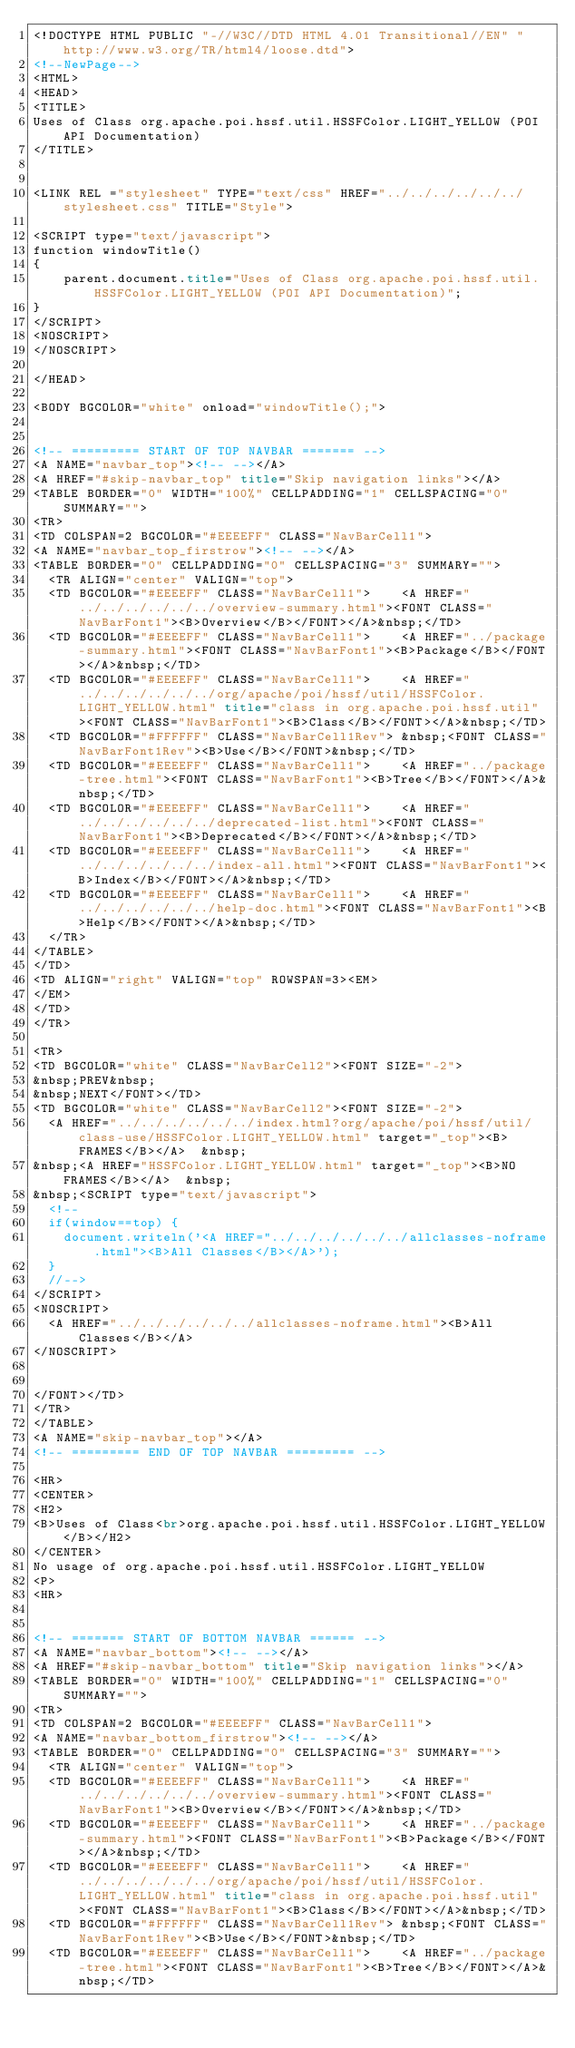<code> <loc_0><loc_0><loc_500><loc_500><_HTML_><!DOCTYPE HTML PUBLIC "-//W3C//DTD HTML 4.01 Transitional//EN" "http://www.w3.org/TR/html4/loose.dtd">
<!--NewPage-->
<HTML>
<HEAD>
<TITLE>
Uses of Class org.apache.poi.hssf.util.HSSFColor.LIGHT_YELLOW (POI API Documentation)
</TITLE>


<LINK REL ="stylesheet" TYPE="text/css" HREF="../../../../../../stylesheet.css" TITLE="Style">

<SCRIPT type="text/javascript">
function windowTitle()
{
    parent.document.title="Uses of Class org.apache.poi.hssf.util.HSSFColor.LIGHT_YELLOW (POI API Documentation)";
}
</SCRIPT>
<NOSCRIPT>
</NOSCRIPT>

</HEAD>

<BODY BGCOLOR="white" onload="windowTitle();">


<!-- ========= START OF TOP NAVBAR ======= -->
<A NAME="navbar_top"><!-- --></A>
<A HREF="#skip-navbar_top" title="Skip navigation links"></A>
<TABLE BORDER="0" WIDTH="100%" CELLPADDING="1" CELLSPACING="0" SUMMARY="">
<TR>
<TD COLSPAN=2 BGCOLOR="#EEEEFF" CLASS="NavBarCell1">
<A NAME="navbar_top_firstrow"><!-- --></A>
<TABLE BORDER="0" CELLPADDING="0" CELLSPACING="3" SUMMARY="">
  <TR ALIGN="center" VALIGN="top">
  <TD BGCOLOR="#EEEEFF" CLASS="NavBarCell1">    <A HREF="../../../../../../overview-summary.html"><FONT CLASS="NavBarFont1"><B>Overview</B></FONT></A>&nbsp;</TD>
  <TD BGCOLOR="#EEEEFF" CLASS="NavBarCell1">    <A HREF="../package-summary.html"><FONT CLASS="NavBarFont1"><B>Package</B></FONT></A>&nbsp;</TD>
  <TD BGCOLOR="#EEEEFF" CLASS="NavBarCell1">    <A HREF="../../../../../../org/apache/poi/hssf/util/HSSFColor.LIGHT_YELLOW.html" title="class in org.apache.poi.hssf.util"><FONT CLASS="NavBarFont1"><B>Class</B></FONT></A>&nbsp;</TD>
  <TD BGCOLOR="#FFFFFF" CLASS="NavBarCell1Rev"> &nbsp;<FONT CLASS="NavBarFont1Rev"><B>Use</B></FONT>&nbsp;</TD>
  <TD BGCOLOR="#EEEEFF" CLASS="NavBarCell1">    <A HREF="../package-tree.html"><FONT CLASS="NavBarFont1"><B>Tree</B></FONT></A>&nbsp;</TD>
  <TD BGCOLOR="#EEEEFF" CLASS="NavBarCell1">    <A HREF="../../../../../../deprecated-list.html"><FONT CLASS="NavBarFont1"><B>Deprecated</B></FONT></A>&nbsp;</TD>
  <TD BGCOLOR="#EEEEFF" CLASS="NavBarCell1">    <A HREF="../../../../../../index-all.html"><FONT CLASS="NavBarFont1"><B>Index</B></FONT></A>&nbsp;</TD>
  <TD BGCOLOR="#EEEEFF" CLASS="NavBarCell1">    <A HREF="../../../../../../help-doc.html"><FONT CLASS="NavBarFont1"><B>Help</B></FONT></A>&nbsp;</TD>
  </TR>
</TABLE>
</TD>
<TD ALIGN="right" VALIGN="top" ROWSPAN=3><EM>
</EM>
</TD>
</TR>

<TR>
<TD BGCOLOR="white" CLASS="NavBarCell2"><FONT SIZE="-2">
&nbsp;PREV&nbsp;
&nbsp;NEXT</FONT></TD>
<TD BGCOLOR="white" CLASS="NavBarCell2"><FONT SIZE="-2">
  <A HREF="../../../../../../index.html?org/apache/poi/hssf/util/class-use/HSSFColor.LIGHT_YELLOW.html" target="_top"><B>FRAMES</B></A>  &nbsp;
&nbsp;<A HREF="HSSFColor.LIGHT_YELLOW.html" target="_top"><B>NO FRAMES</B></A>  &nbsp;
&nbsp;<SCRIPT type="text/javascript">
  <!--
  if(window==top) {
    document.writeln('<A HREF="../../../../../../allclasses-noframe.html"><B>All Classes</B></A>');
  }
  //-->
</SCRIPT>
<NOSCRIPT>
  <A HREF="../../../../../../allclasses-noframe.html"><B>All Classes</B></A>
</NOSCRIPT>


</FONT></TD>
</TR>
</TABLE>
<A NAME="skip-navbar_top"></A>
<!-- ========= END OF TOP NAVBAR ========= -->

<HR>
<CENTER>
<H2>
<B>Uses of Class<br>org.apache.poi.hssf.util.HSSFColor.LIGHT_YELLOW</B></H2>
</CENTER>
No usage of org.apache.poi.hssf.util.HSSFColor.LIGHT_YELLOW
<P>
<HR>


<!-- ======= START OF BOTTOM NAVBAR ====== -->
<A NAME="navbar_bottom"><!-- --></A>
<A HREF="#skip-navbar_bottom" title="Skip navigation links"></A>
<TABLE BORDER="0" WIDTH="100%" CELLPADDING="1" CELLSPACING="0" SUMMARY="">
<TR>
<TD COLSPAN=2 BGCOLOR="#EEEEFF" CLASS="NavBarCell1">
<A NAME="navbar_bottom_firstrow"><!-- --></A>
<TABLE BORDER="0" CELLPADDING="0" CELLSPACING="3" SUMMARY="">
  <TR ALIGN="center" VALIGN="top">
  <TD BGCOLOR="#EEEEFF" CLASS="NavBarCell1">    <A HREF="../../../../../../overview-summary.html"><FONT CLASS="NavBarFont1"><B>Overview</B></FONT></A>&nbsp;</TD>
  <TD BGCOLOR="#EEEEFF" CLASS="NavBarCell1">    <A HREF="../package-summary.html"><FONT CLASS="NavBarFont1"><B>Package</B></FONT></A>&nbsp;</TD>
  <TD BGCOLOR="#EEEEFF" CLASS="NavBarCell1">    <A HREF="../../../../../../org/apache/poi/hssf/util/HSSFColor.LIGHT_YELLOW.html" title="class in org.apache.poi.hssf.util"><FONT CLASS="NavBarFont1"><B>Class</B></FONT></A>&nbsp;</TD>
  <TD BGCOLOR="#FFFFFF" CLASS="NavBarCell1Rev"> &nbsp;<FONT CLASS="NavBarFont1Rev"><B>Use</B></FONT>&nbsp;</TD>
  <TD BGCOLOR="#EEEEFF" CLASS="NavBarCell1">    <A HREF="../package-tree.html"><FONT CLASS="NavBarFont1"><B>Tree</B></FONT></A>&nbsp;</TD></code> 